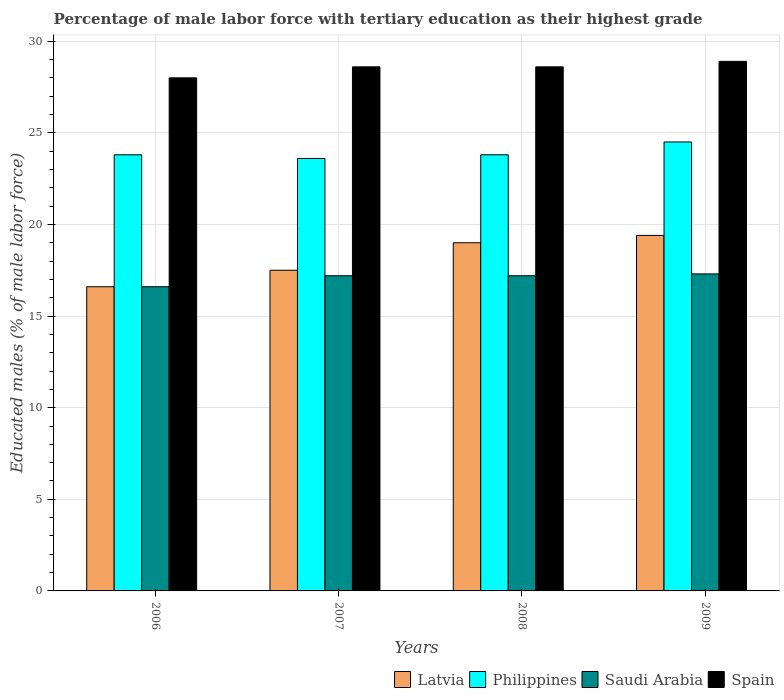Are the number of bars per tick equal to the number of legend labels?
Provide a succinct answer. Yes. Are the number of bars on each tick of the X-axis equal?
Provide a short and direct response. Yes. How many bars are there on the 2nd tick from the left?
Your response must be concise. 4. What is the percentage of male labor force with tertiary education in Philippines in 2006?
Your response must be concise. 23.8. Across all years, what is the maximum percentage of male labor force with tertiary education in Philippines?
Offer a very short reply. 24.5. Across all years, what is the minimum percentage of male labor force with tertiary education in Philippines?
Ensure brevity in your answer.  23.6. In which year was the percentage of male labor force with tertiary education in Philippines minimum?
Offer a terse response. 2007. What is the total percentage of male labor force with tertiary education in Philippines in the graph?
Offer a very short reply. 95.7. What is the difference between the percentage of male labor force with tertiary education in Saudi Arabia in 2006 and that in 2009?
Provide a short and direct response. -0.7. What is the difference between the percentage of male labor force with tertiary education in Spain in 2009 and the percentage of male labor force with tertiary education in Philippines in 2006?
Offer a terse response. 5.1. What is the average percentage of male labor force with tertiary education in Spain per year?
Give a very brief answer. 28.53. In the year 2009, what is the difference between the percentage of male labor force with tertiary education in Philippines and percentage of male labor force with tertiary education in Latvia?
Your answer should be very brief. 5.1. What is the ratio of the percentage of male labor force with tertiary education in Philippines in 2006 to that in 2007?
Offer a very short reply. 1.01. Is the percentage of male labor force with tertiary education in Saudi Arabia in 2007 less than that in 2009?
Keep it short and to the point. Yes. Is the difference between the percentage of male labor force with tertiary education in Philippines in 2006 and 2007 greater than the difference between the percentage of male labor force with tertiary education in Latvia in 2006 and 2007?
Offer a very short reply. Yes. What is the difference between the highest and the second highest percentage of male labor force with tertiary education in Latvia?
Your answer should be compact. 0.4. What is the difference between the highest and the lowest percentage of male labor force with tertiary education in Latvia?
Ensure brevity in your answer.  2.8. Is the sum of the percentage of male labor force with tertiary education in Philippines in 2006 and 2009 greater than the maximum percentage of male labor force with tertiary education in Latvia across all years?
Keep it short and to the point. Yes. Is it the case that in every year, the sum of the percentage of male labor force with tertiary education in Spain and percentage of male labor force with tertiary education in Saudi Arabia is greater than the sum of percentage of male labor force with tertiary education in Philippines and percentage of male labor force with tertiary education in Latvia?
Give a very brief answer. Yes. What does the 1st bar from the left in 2009 represents?
Ensure brevity in your answer.  Latvia. How many years are there in the graph?
Ensure brevity in your answer.  4. What is the difference between two consecutive major ticks on the Y-axis?
Give a very brief answer. 5. How many legend labels are there?
Your answer should be compact. 4. What is the title of the graph?
Make the answer very short. Percentage of male labor force with tertiary education as their highest grade. Does "Tonga" appear as one of the legend labels in the graph?
Provide a succinct answer. No. What is the label or title of the Y-axis?
Provide a succinct answer. Educated males (% of male labor force). What is the Educated males (% of male labor force) in Latvia in 2006?
Make the answer very short. 16.6. What is the Educated males (% of male labor force) of Philippines in 2006?
Provide a succinct answer. 23.8. What is the Educated males (% of male labor force) of Saudi Arabia in 2006?
Keep it short and to the point. 16.6. What is the Educated males (% of male labor force) in Latvia in 2007?
Provide a succinct answer. 17.5. What is the Educated males (% of male labor force) in Philippines in 2007?
Provide a short and direct response. 23.6. What is the Educated males (% of male labor force) in Saudi Arabia in 2007?
Your answer should be very brief. 17.2. What is the Educated males (% of male labor force) in Spain in 2007?
Your answer should be compact. 28.6. What is the Educated males (% of male labor force) of Latvia in 2008?
Offer a terse response. 19. What is the Educated males (% of male labor force) of Philippines in 2008?
Make the answer very short. 23.8. What is the Educated males (% of male labor force) in Saudi Arabia in 2008?
Your answer should be very brief. 17.2. What is the Educated males (% of male labor force) in Spain in 2008?
Give a very brief answer. 28.6. What is the Educated males (% of male labor force) in Latvia in 2009?
Give a very brief answer. 19.4. What is the Educated males (% of male labor force) of Saudi Arabia in 2009?
Your response must be concise. 17.3. What is the Educated males (% of male labor force) of Spain in 2009?
Offer a terse response. 28.9. Across all years, what is the maximum Educated males (% of male labor force) of Latvia?
Your response must be concise. 19.4. Across all years, what is the maximum Educated males (% of male labor force) of Saudi Arabia?
Ensure brevity in your answer.  17.3. Across all years, what is the maximum Educated males (% of male labor force) of Spain?
Your answer should be compact. 28.9. Across all years, what is the minimum Educated males (% of male labor force) of Latvia?
Give a very brief answer. 16.6. Across all years, what is the minimum Educated males (% of male labor force) in Philippines?
Your response must be concise. 23.6. Across all years, what is the minimum Educated males (% of male labor force) of Saudi Arabia?
Your answer should be compact. 16.6. What is the total Educated males (% of male labor force) of Latvia in the graph?
Keep it short and to the point. 72.5. What is the total Educated males (% of male labor force) in Philippines in the graph?
Ensure brevity in your answer.  95.7. What is the total Educated males (% of male labor force) in Saudi Arabia in the graph?
Make the answer very short. 68.3. What is the total Educated males (% of male labor force) of Spain in the graph?
Provide a short and direct response. 114.1. What is the difference between the Educated males (% of male labor force) in Latvia in 2006 and that in 2007?
Your answer should be compact. -0.9. What is the difference between the Educated males (% of male labor force) of Saudi Arabia in 2006 and that in 2007?
Your answer should be compact. -0.6. What is the difference between the Educated males (% of male labor force) in Philippines in 2006 and that in 2008?
Your response must be concise. 0. What is the difference between the Educated males (% of male labor force) in Saudi Arabia in 2006 and that in 2008?
Make the answer very short. -0.6. What is the difference between the Educated males (% of male labor force) in Spain in 2006 and that in 2008?
Provide a short and direct response. -0.6. What is the difference between the Educated males (% of male labor force) of Latvia in 2006 and that in 2009?
Keep it short and to the point. -2.8. What is the difference between the Educated males (% of male labor force) of Spain in 2006 and that in 2009?
Your answer should be very brief. -0.9. What is the difference between the Educated males (% of male labor force) of Philippines in 2007 and that in 2008?
Keep it short and to the point. -0.2. What is the difference between the Educated males (% of male labor force) of Spain in 2007 and that in 2008?
Provide a short and direct response. 0. What is the difference between the Educated males (% of male labor force) in Philippines in 2007 and that in 2009?
Provide a succinct answer. -0.9. What is the difference between the Educated males (% of male labor force) in Spain in 2008 and that in 2009?
Provide a short and direct response. -0.3. What is the difference between the Educated males (% of male labor force) in Latvia in 2006 and the Educated males (% of male labor force) in Saudi Arabia in 2007?
Provide a short and direct response. -0.6. What is the difference between the Educated males (% of male labor force) of Philippines in 2006 and the Educated males (% of male labor force) of Saudi Arabia in 2007?
Make the answer very short. 6.6. What is the difference between the Educated males (% of male labor force) in Latvia in 2006 and the Educated males (% of male labor force) in Philippines in 2008?
Offer a very short reply. -7.2. What is the difference between the Educated males (% of male labor force) in Latvia in 2006 and the Educated males (% of male labor force) in Saudi Arabia in 2008?
Offer a very short reply. -0.6. What is the difference between the Educated males (% of male labor force) in Latvia in 2006 and the Educated males (% of male labor force) in Philippines in 2009?
Offer a terse response. -7.9. What is the difference between the Educated males (% of male labor force) of Latvia in 2006 and the Educated males (% of male labor force) of Saudi Arabia in 2009?
Your answer should be very brief. -0.7. What is the difference between the Educated males (% of male labor force) in Philippines in 2006 and the Educated males (% of male labor force) in Spain in 2009?
Your answer should be very brief. -5.1. What is the difference between the Educated males (% of male labor force) in Latvia in 2007 and the Educated males (% of male labor force) in Saudi Arabia in 2008?
Make the answer very short. 0.3. What is the difference between the Educated males (% of male labor force) in Latvia in 2007 and the Educated males (% of male labor force) in Spain in 2008?
Give a very brief answer. -11.1. What is the difference between the Educated males (% of male labor force) in Philippines in 2007 and the Educated males (% of male labor force) in Spain in 2008?
Ensure brevity in your answer.  -5. What is the difference between the Educated males (% of male labor force) of Saudi Arabia in 2007 and the Educated males (% of male labor force) of Spain in 2008?
Your response must be concise. -11.4. What is the difference between the Educated males (% of male labor force) of Latvia in 2007 and the Educated males (% of male labor force) of Philippines in 2009?
Provide a succinct answer. -7. What is the difference between the Educated males (% of male labor force) of Philippines in 2007 and the Educated males (% of male labor force) of Saudi Arabia in 2009?
Your answer should be very brief. 6.3. What is the difference between the Educated males (% of male labor force) in Philippines in 2007 and the Educated males (% of male labor force) in Spain in 2009?
Offer a terse response. -5.3. What is the difference between the Educated males (% of male labor force) in Saudi Arabia in 2007 and the Educated males (% of male labor force) in Spain in 2009?
Your response must be concise. -11.7. What is the difference between the Educated males (% of male labor force) in Latvia in 2008 and the Educated males (% of male labor force) in Philippines in 2009?
Give a very brief answer. -5.5. What is the difference between the Educated males (% of male labor force) in Saudi Arabia in 2008 and the Educated males (% of male labor force) in Spain in 2009?
Keep it short and to the point. -11.7. What is the average Educated males (% of male labor force) of Latvia per year?
Offer a terse response. 18.12. What is the average Educated males (% of male labor force) in Philippines per year?
Give a very brief answer. 23.93. What is the average Educated males (% of male labor force) in Saudi Arabia per year?
Provide a short and direct response. 17.07. What is the average Educated males (% of male labor force) in Spain per year?
Offer a terse response. 28.52. In the year 2006, what is the difference between the Educated males (% of male labor force) of Latvia and Educated males (% of male labor force) of Philippines?
Offer a terse response. -7.2. In the year 2006, what is the difference between the Educated males (% of male labor force) in Philippines and Educated males (% of male labor force) in Saudi Arabia?
Make the answer very short. 7.2. In the year 2006, what is the difference between the Educated males (% of male labor force) of Philippines and Educated males (% of male labor force) of Spain?
Make the answer very short. -4.2. In the year 2007, what is the difference between the Educated males (% of male labor force) of Latvia and Educated males (% of male labor force) of Philippines?
Keep it short and to the point. -6.1. In the year 2007, what is the difference between the Educated males (% of male labor force) in Saudi Arabia and Educated males (% of male labor force) in Spain?
Make the answer very short. -11.4. In the year 2008, what is the difference between the Educated males (% of male labor force) in Latvia and Educated males (% of male labor force) in Saudi Arabia?
Keep it short and to the point. 1.8. In the year 2008, what is the difference between the Educated males (% of male labor force) in Philippines and Educated males (% of male labor force) in Saudi Arabia?
Keep it short and to the point. 6.6. In the year 2008, what is the difference between the Educated males (% of male labor force) of Saudi Arabia and Educated males (% of male labor force) of Spain?
Provide a succinct answer. -11.4. In the year 2009, what is the difference between the Educated males (% of male labor force) in Latvia and Educated males (% of male labor force) in Philippines?
Provide a succinct answer. -5.1. In the year 2009, what is the difference between the Educated males (% of male labor force) of Latvia and Educated males (% of male labor force) of Spain?
Give a very brief answer. -9.5. In the year 2009, what is the difference between the Educated males (% of male labor force) in Saudi Arabia and Educated males (% of male labor force) in Spain?
Your answer should be very brief. -11.6. What is the ratio of the Educated males (% of male labor force) in Latvia in 2006 to that in 2007?
Make the answer very short. 0.95. What is the ratio of the Educated males (% of male labor force) in Philippines in 2006 to that in 2007?
Your answer should be compact. 1.01. What is the ratio of the Educated males (% of male labor force) of Saudi Arabia in 2006 to that in 2007?
Offer a very short reply. 0.97. What is the ratio of the Educated males (% of male labor force) of Latvia in 2006 to that in 2008?
Make the answer very short. 0.87. What is the ratio of the Educated males (% of male labor force) in Saudi Arabia in 2006 to that in 2008?
Give a very brief answer. 0.97. What is the ratio of the Educated males (% of male labor force) in Spain in 2006 to that in 2008?
Your response must be concise. 0.98. What is the ratio of the Educated males (% of male labor force) in Latvia in 2006 to that in 2009?
Provide a short and direct response. 0.86. What is the ratio of the Educated males (% of male labor force) in Philippines in 2006 to that in 2009?
Make the answer very short. 0.97. What is the ratio of the Educated males (% of male labor force) of Saudi Arabia in 2006 to that in 2009?
Your answer should be compact. 0.96. What is the ratio of the Educated males (% of male labor force) in Spain in 2006 to that in 2009?
Offer a very short reply. 0.97. What is the ratio of the Educated males (% of male labor force) of Latvia in 2007 to that in 2008?
Offer a terse response. 0.92. What is the ratio of the Educated males (% of male labor force) in Spain in 2007 to that in 2008?
Offer a terse response. 1. What is the ratio of the Educated males (% of male labor force) of Latvia in 2007 to that in 2009?
Give a very brief answer. 0.9. What is the ratio of the Educated males (% of male labor force) of Philippines in 2007 to that in 2009?
Make the answer very short. 0.96. What is the ratio of the Educated males (% of male labor force) of Spain in 2007 to that in 2009?
Offer a very short reply. 0.99. What is the ratio of the Educated males (% of male labor force) of Latvia in 2008 to that in 2009?
Make the answer very short. 0.98. What is the ratio of the Educated males (% of male labor force) in Philippines in 2008 to that in 2009?
Offer a very short reply. 0.97. What is the ratio of the Educated males (% of male labor force) in Saudi Arabia in 2008 to that in 2009?
Keep it short and to the point. 0.99. What is the difference between the highest and the second highest Educated males (% of male labor force) of Latvia?
Your answer should be very brief. 0.4. What is the difference between the highest and the second highest Educated males (% of male labor force) in Philippines?
Your answer should be very brief. 0.7. What is the difference between the highest and the lowest Educated males (% of male labor force) in Philippines?
Ensure brevity in your answer.  0.9. What is the difference between the highest and the lowest Educated males (% of male labor force) in Saudi Arabia?
Keep it short and to the point. 0.7. 